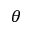<formula> <loc_0><loc_0><loc_500><loc_500>\theta</formula> 